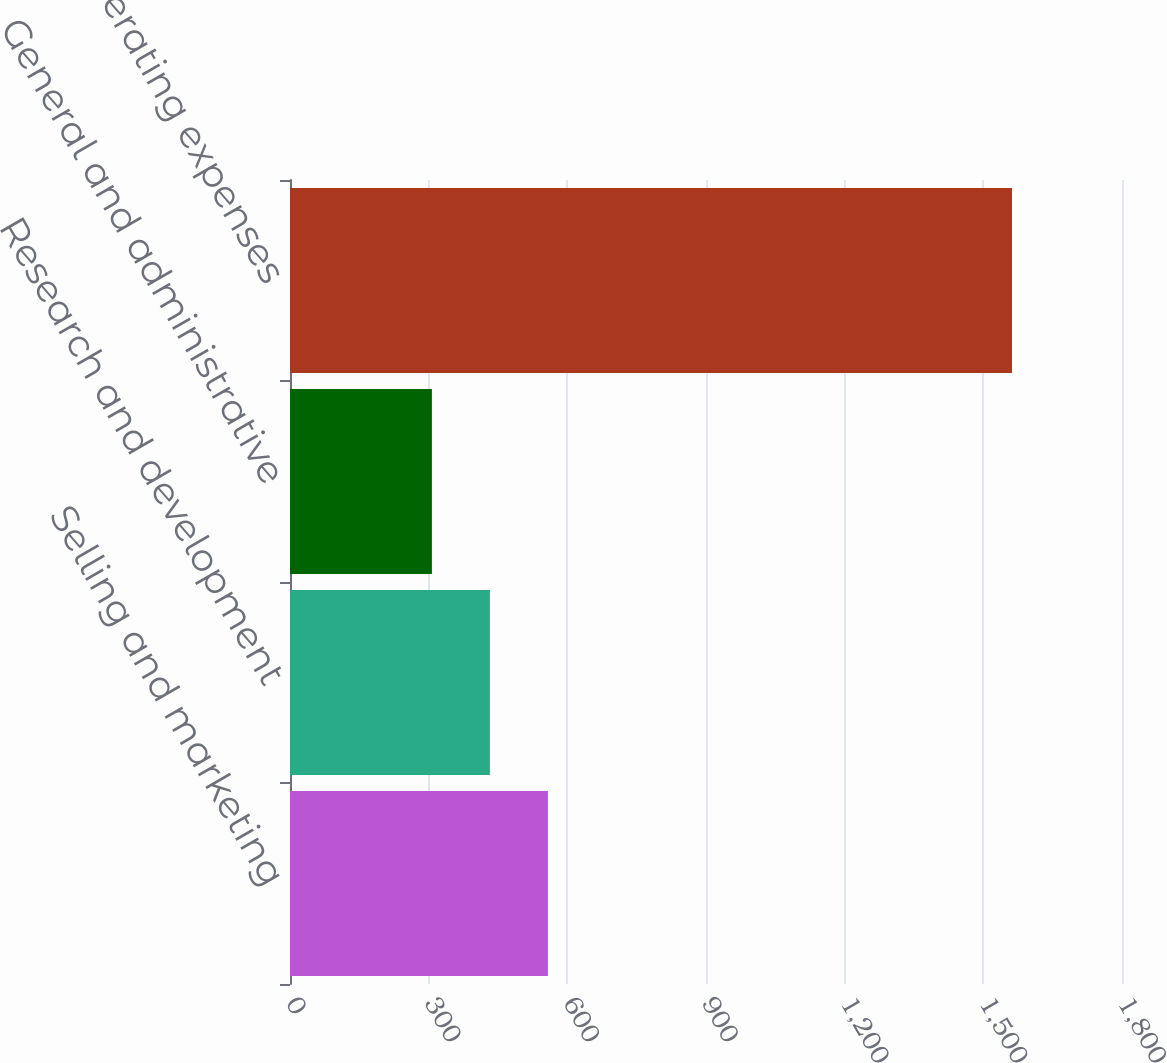Convert chart to OTSL. <chart><loc_0><loc_0><loc_500><loc_500><bar_chart><fcel>Selling and marketing<fcel>Research and development<fcel>General and administrative<fcel>Total Operating expenses<nl><fcel>558<fcel>432.5<fcel>307<fcel>1562<nl></chart> 